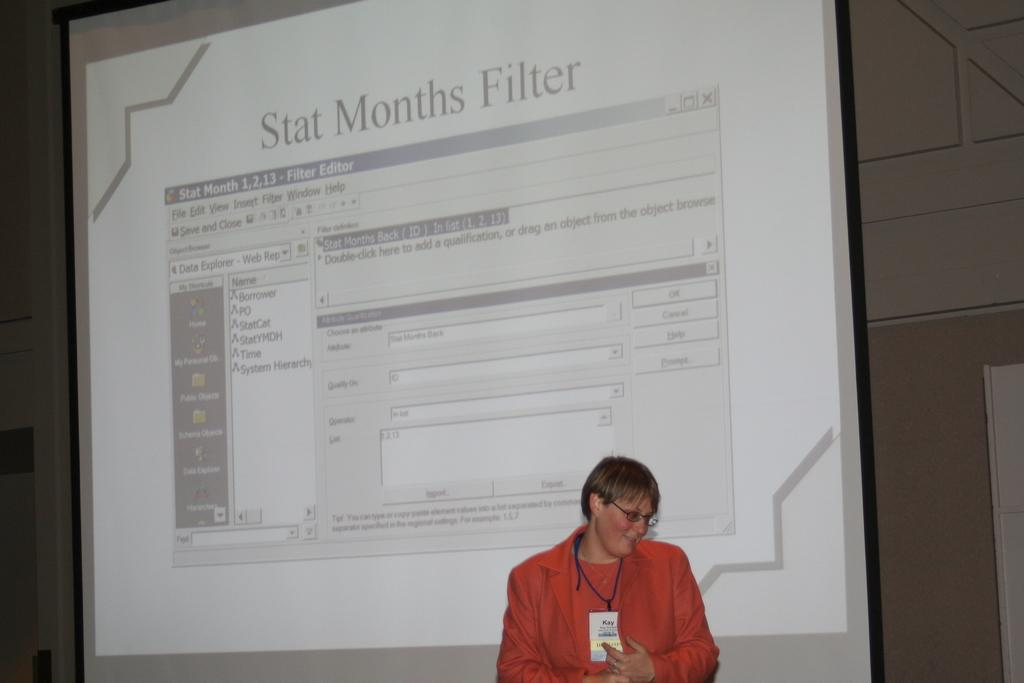Who is present in the image? There is a woman in the image. What is the woman wearing? The woman is wearing spectacles. What can be seen in the background of the image? There is a screen and a wall in the background of the image. What is displayed on the screen? App icons and some information are visible on the screen. What type of powder is being used to support the school in the image? There is no powder or school present in the image. What type of support is the woman providing to the school in the image? There is no school or support being provided by the woman in the image. 